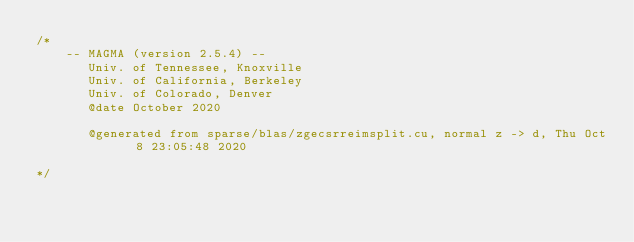Convert code to text. <code><loc_0><loc_0><loc_500><loc_500><_Cuda_>/*
    -- MAGMA (version 2.5.4) --
       Univ. of Tennessee, Knoxville
       Univ. of California, Berkeley
       Univ. of Colorado, Denver
       @date October 2020

       @generated from sparse/blas/zgecsrreimsplit.cu, normal z -> d, Thu Oct  8 23:05:48 2020

*/</code> 